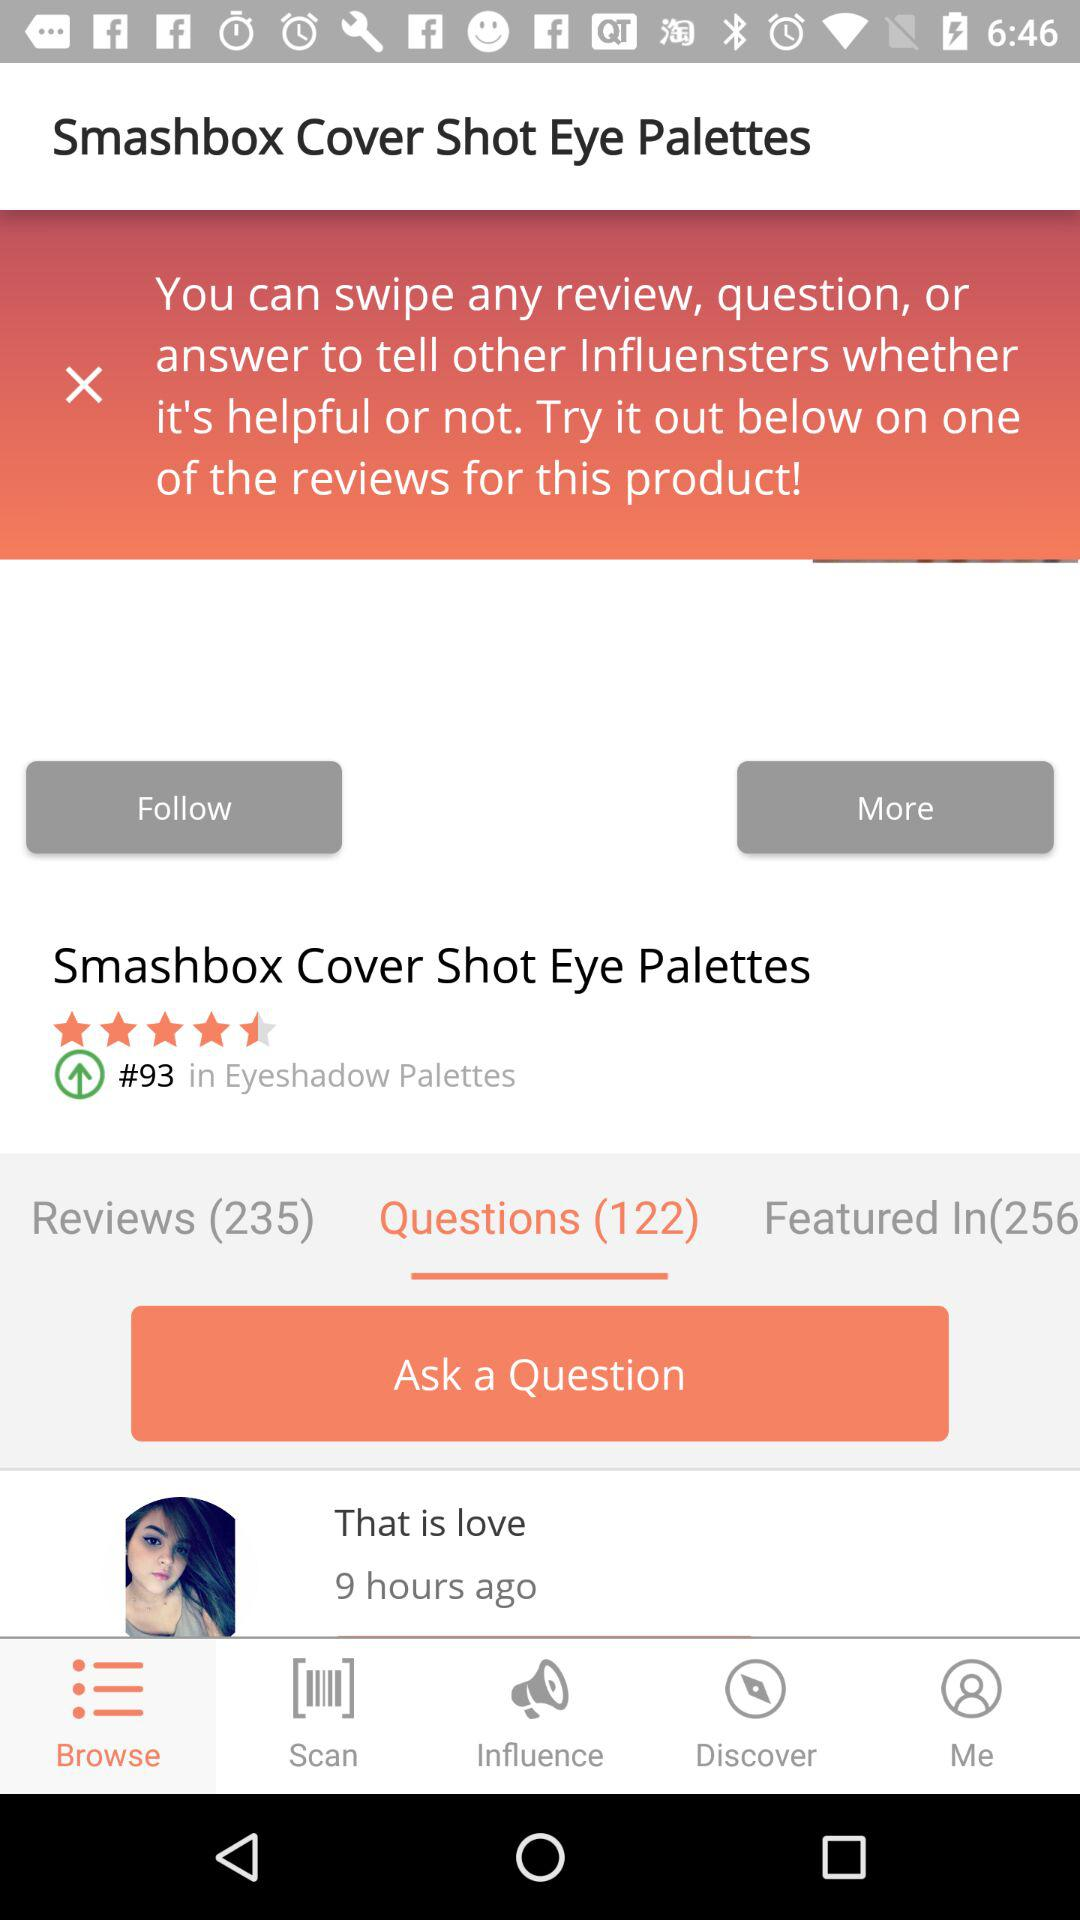How many reviews does the product have?
Answer the question using a single word or phrase. 235 